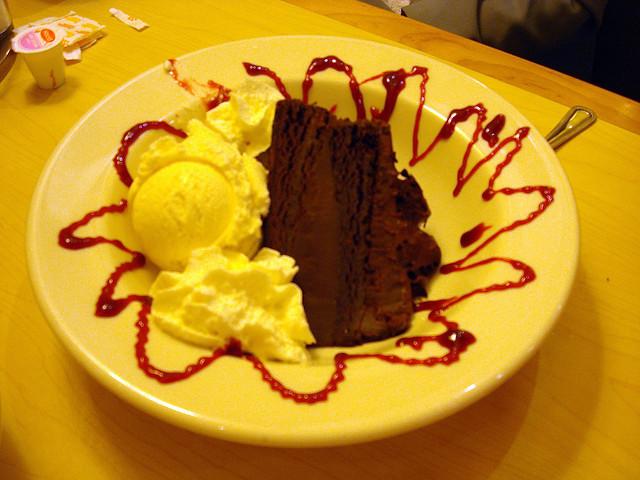What design did the syrup do?
Answer briefly. Flower. Does the ice cream taste like Chocolate?
Concise answer only. No. Is the creamer open or unopened?
Short answer required. Unopened. 